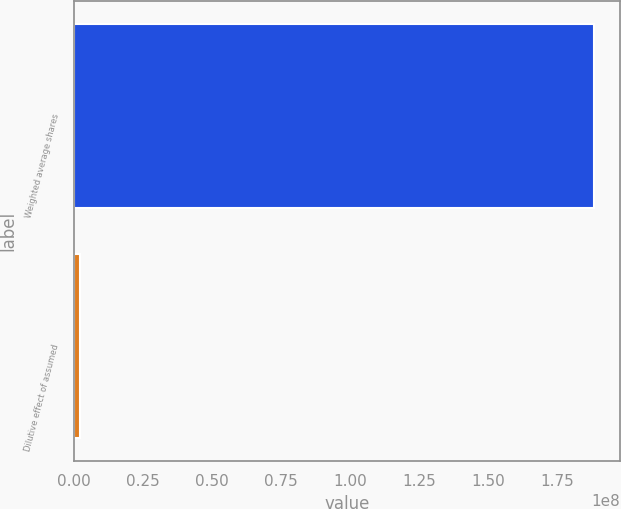Convert chart. <chart><loc_0><loc_0><loc_500><loc_500><bar_chart><fcel>Weighted average shares<fcel>Dilutive effect of assumed<nl><fcel>1.88398e+08<fcel>2.276e+06<nl></chart> 